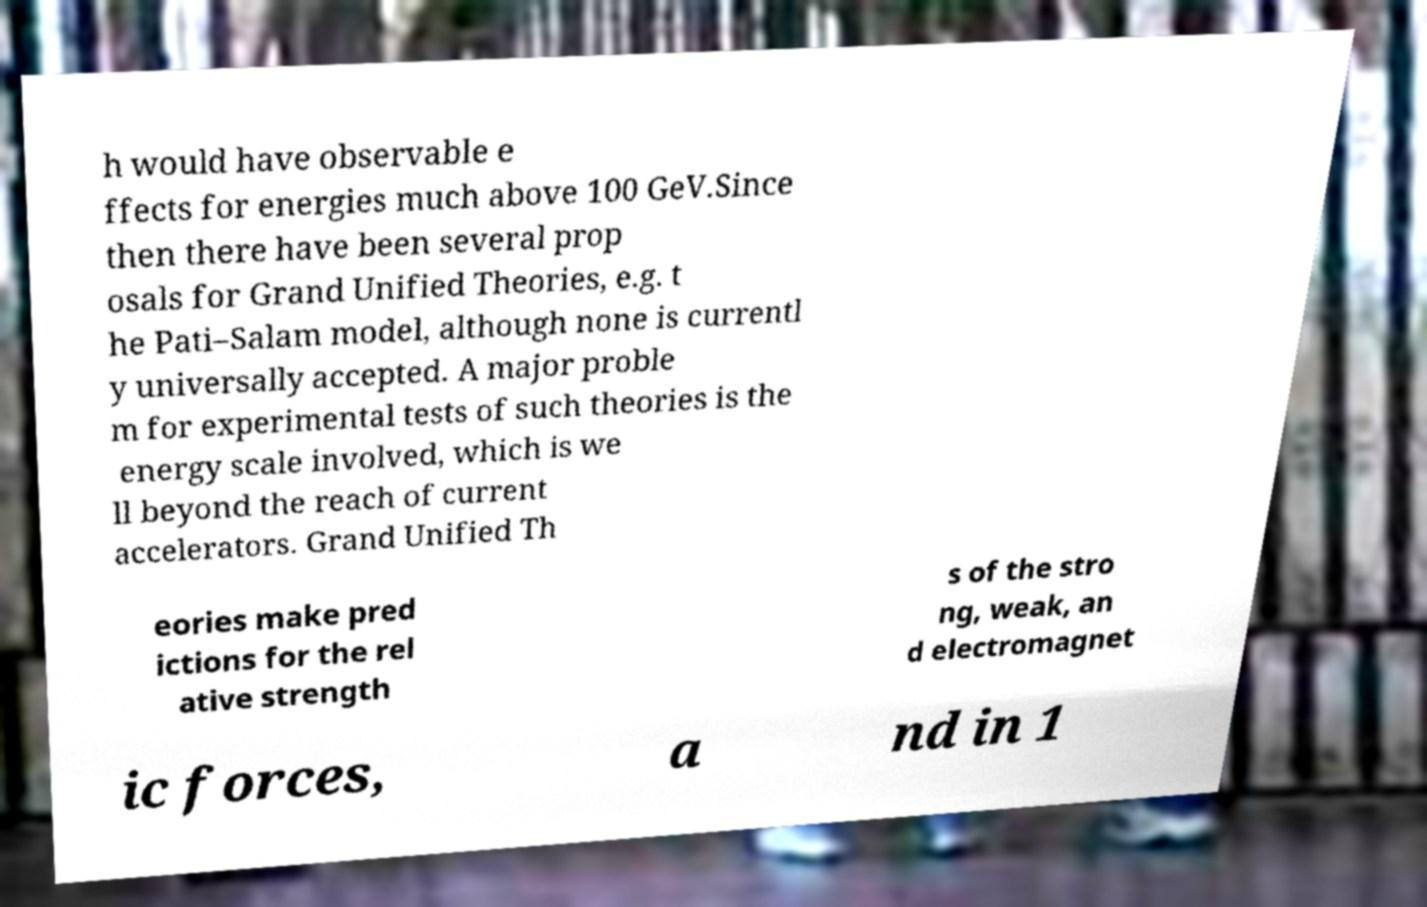There's text embedded in this image that I need extracted. Can you transcribe it verbatim? h would have observable e ffects for energies much above 100 GeV.Since then there have been several prop osals for Grand Unified Theories, e.g. t he Pati–Salam model, although none is currentl y universally accepted. A major proble m for experimental tests of such theories is the energy scale involved, which is we ll beyond the reach of current accelerators. Grand Unified Th eories make pred ictions for the rel ative strength s of the stro ng, weak, an d electromagnet ic forces, a nd in 1 